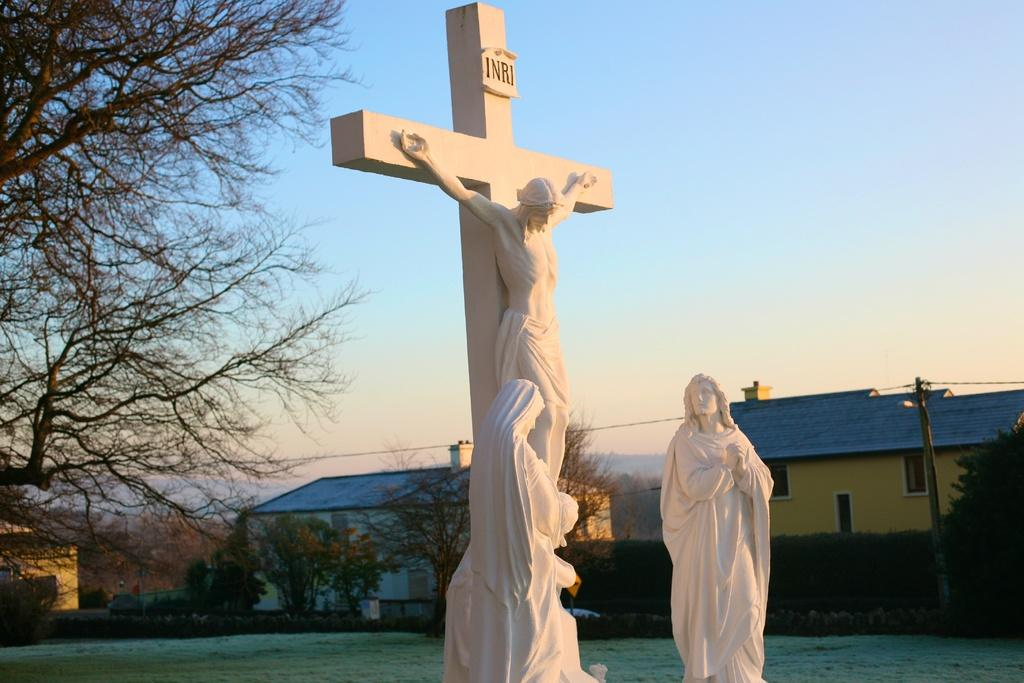<image>
Offer a succinct explanation of the picture presented. Two religious statues one of a cross and Jesus in it and with the words INRI on top the other one looking at the Jesus statue. 